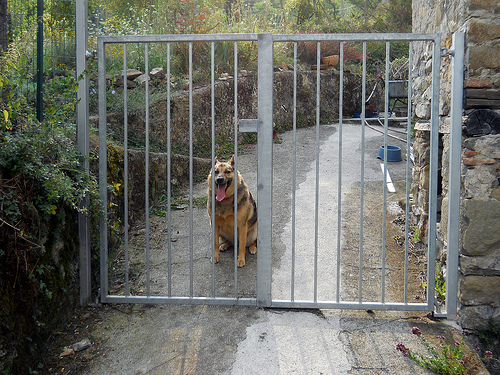<image>
Is the gate to the right of the dog? No. The gate is not to the right of the dog. The horizontal positioning shows a different relationship. Where is the dog in relation to the gate? Is it in front of the gate? No. The dog is not in front of the gate. The spatial positioning shows a different relationship between these objects. Is the dog in front of the fence? No. The dog is not in front of the fence. The spatial positioning shows a different relationship between these objects. 